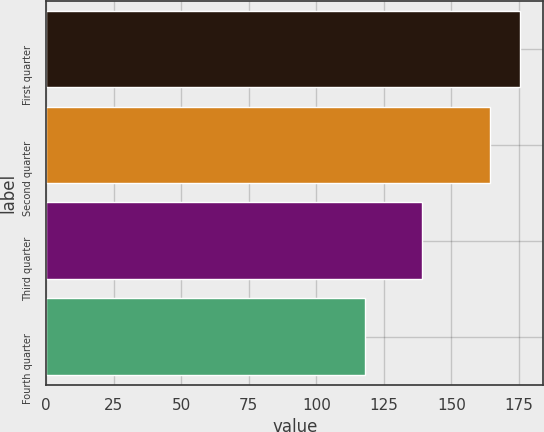Convert chart to OTSL. <chart><loc_0><loc_0><loc_500><loc_500><bar_chart><fcel>First quarter<fcel>Second quarter<fcel>Third quarter<fcel>Fourth quarter<nl><fcel>175.34<fcel>164.4<fcel>139.25<fcel>118.07<nl></chart> 